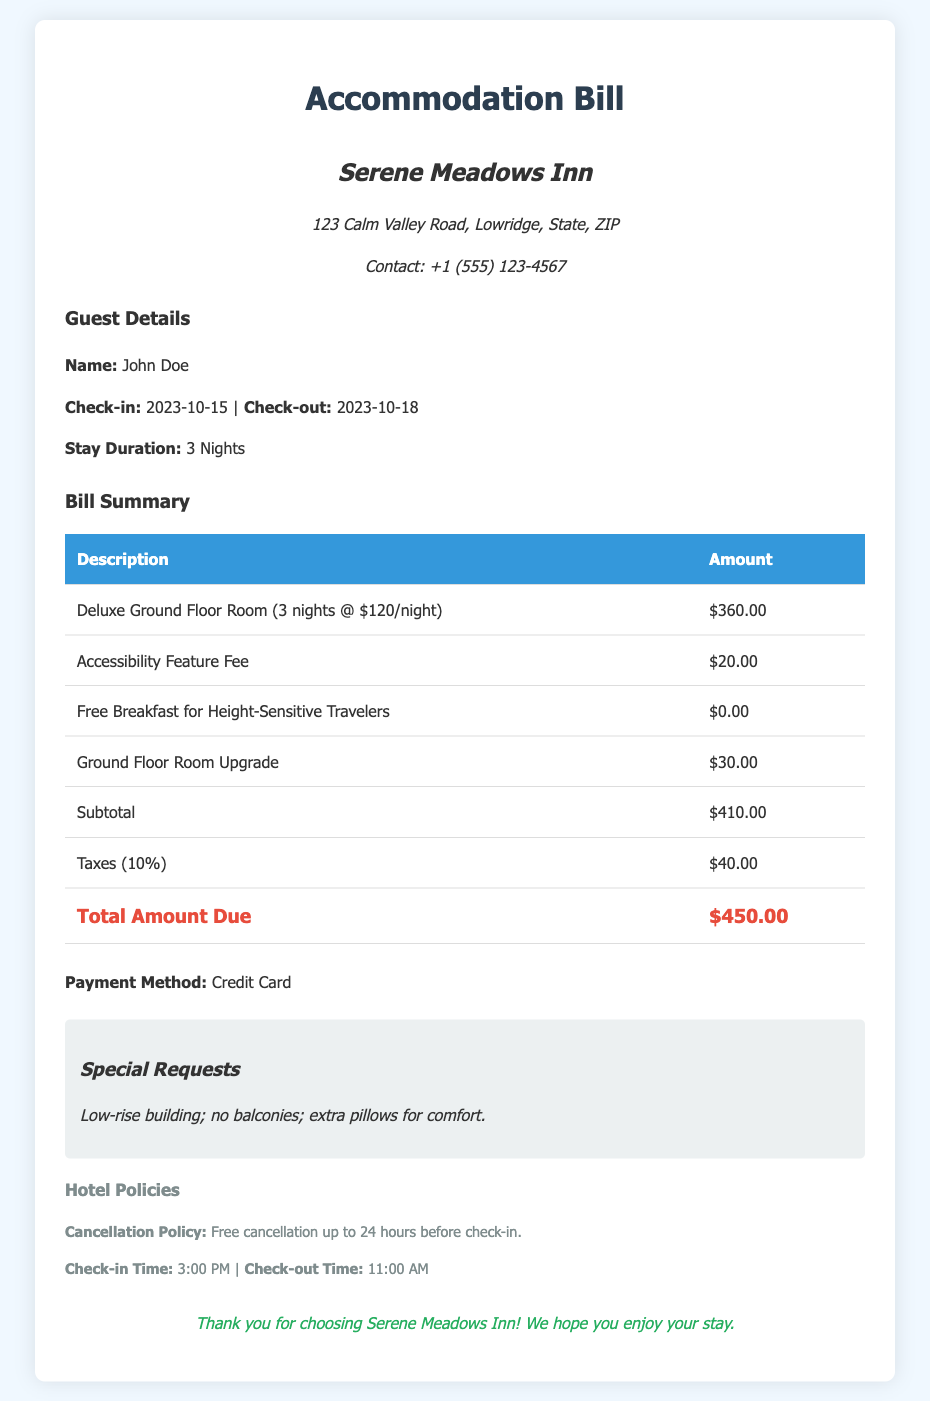What is the name of the hotel? The hotel is named "Serene Meadows Inn."
Answer: Serene Meadows Inn What is the total amount due? The total amount due is listed as $450.00.
Answer: $450.00 How many nights did John Doe stay? John Doe's stay duration is specified as 3 nights.
Answer: 3 Nights What is the rate for the Deluxe Ground Floor Room per night? The rate is noted as $120 per night.
Answer: $120/night What is the fee for accessibility features? The accessibility feature fee is $20.00.
Answer: $20.00 What time is the check-out? The check-out time is specified as 11:00 AM.
Answer: 11:00 AM Did John Doe request any special amenities? Yes, John Doe requested extra pillows for comfort.
Answer: Extra pillows What method of payment was used? The payment method used is indicated as credit card.
Answer: Credit Card How much was charged for the Ground Floor Room Upgrade? The charge for the Ground Floor Room Upgrade is $30.00.
Answer: $30.00 